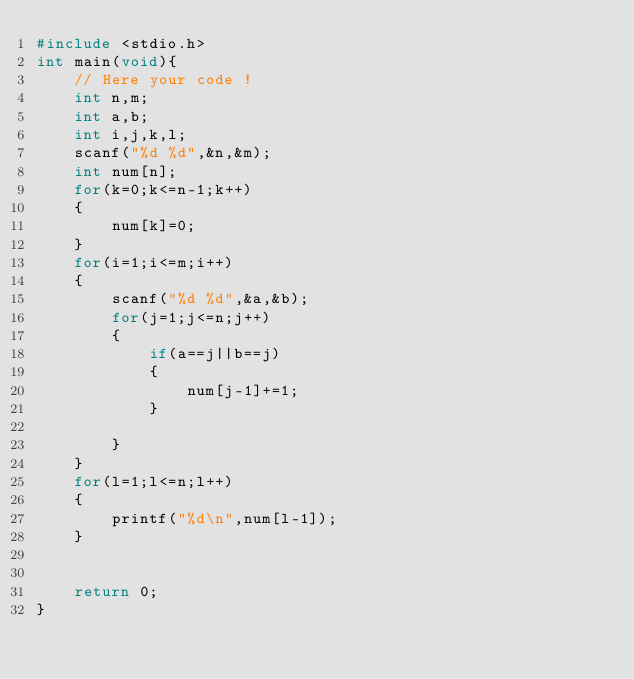Convert code to text. <code><loc_0><loc_0><loc_500><loc_500><_C_>#include <stdio.h>
int main(void){
    // Here your code !
    int n,m;
    int a,b;
    int i,j,k,l;
    scanf("%d %d",&n,&m);
    int num[n];
    for(k=0;k<=n-1;k++)
    {
        num[k]=0;
    }
    for(i=1;i<=m;i++)
    {
        scanf("%d %d",&a,&b);
        for(j=1;j<=n;j++)
        {
            if(a==j||b==j)
            {
                num[j-1]+=1;
            }
            
        }
    }
    for(l=1;l<=n;l++)
    {
        printf("%d\n",num[l-1]);
    }
 
    
    return 0;
}
</code> 